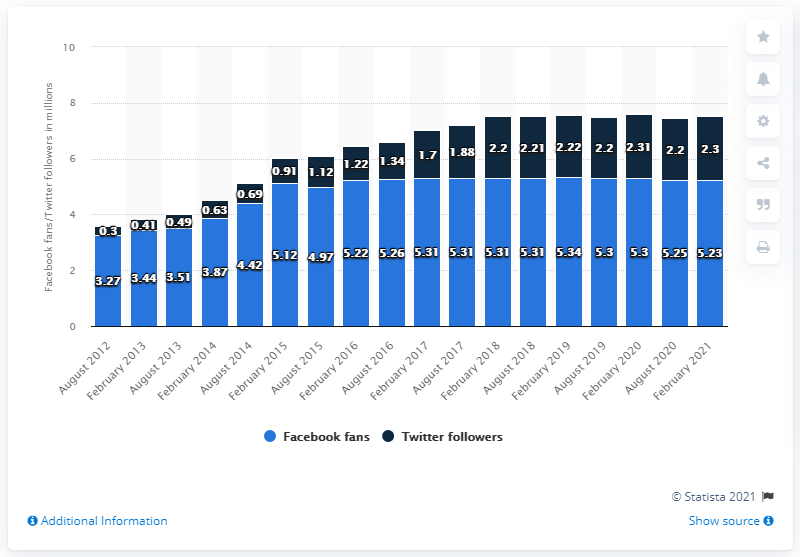Give some essential details in this illustration. The Green Bay Packers football team had 5.23 million Facebook followers in February 2021. 